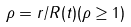<formula> <loc_0><loc_0><loc_500><loc_500>\rho = r / R ( t ) ( \rho \geq 1 )</formula> 